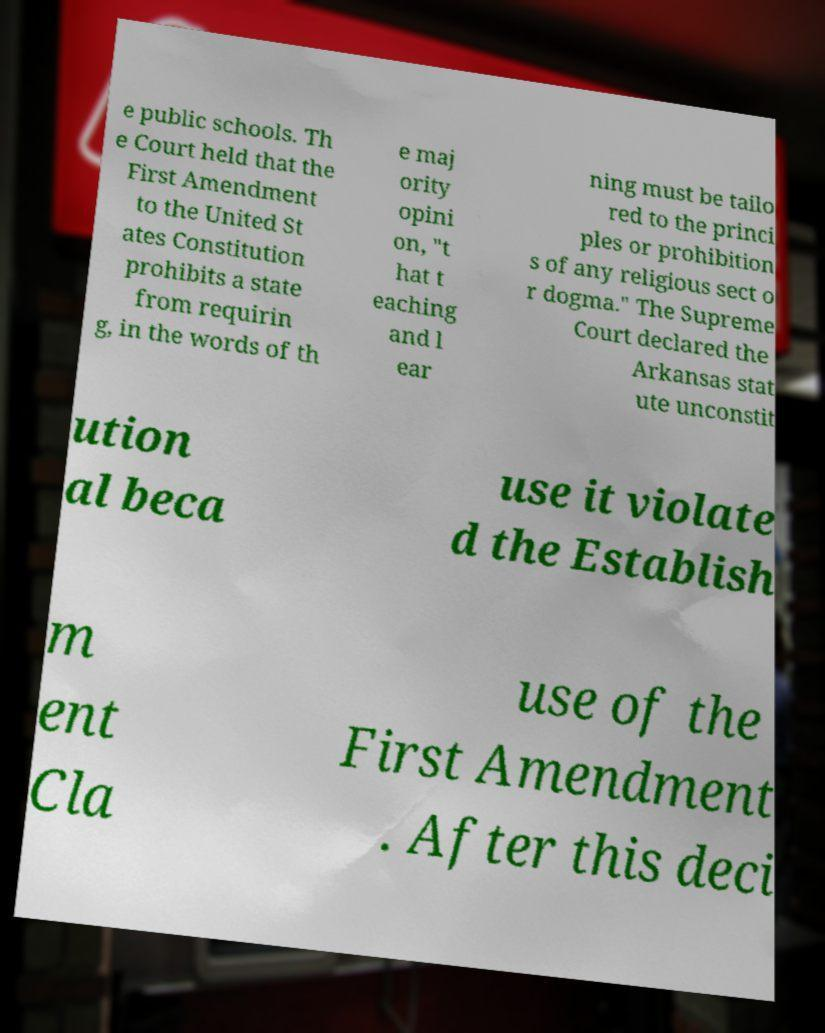What messages or text are displayed in this image? I need them in a readable, typed format. e public schools. Th e Court held that the First Amendment to the United St ates Constitution prohibits a state from requirin g, in the words of th e maj ority opini on, "t hat t eaching and l ear ning must be tailo red to the princi ples or prohibition s of any religious sect o r dogma." The Supreme Court declared the Arkansas stat ute unconstit ution al beca use it violate d the Establish m ent Cla use of the First Amendment . After this deci 